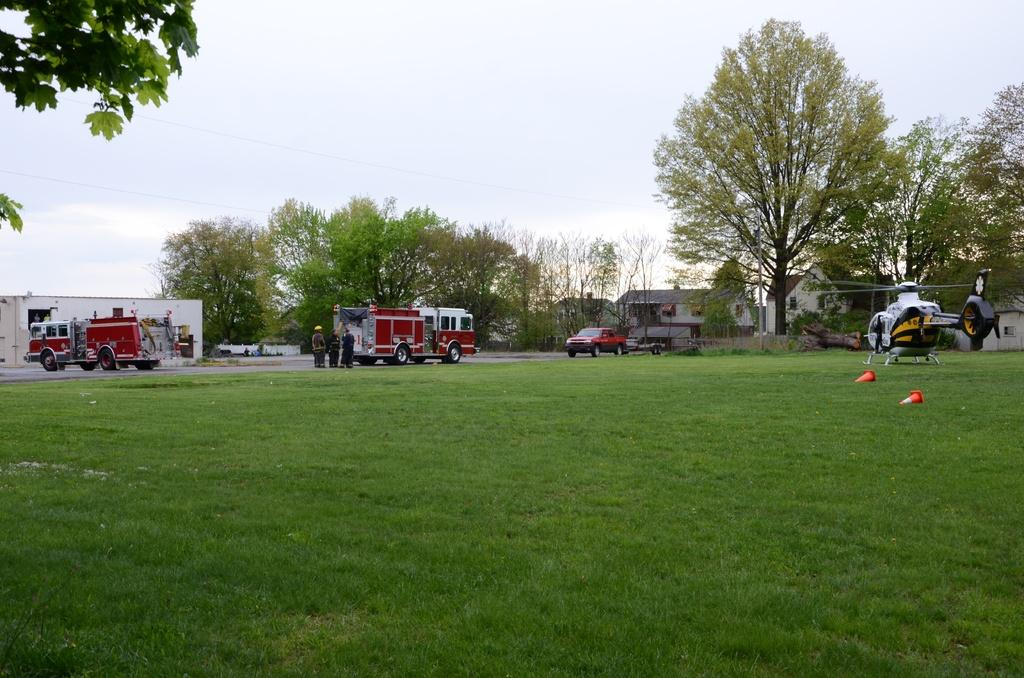What type of vegetation is present on the ground in the center of the image? There is grass on the ground in the center of the image. What can be seen in the background of the image? There are vehicles, trees, and buildings in the background of the image. What type of aircraft is located on the right side of the image? There is a helicopter on the right side of the image. What type of yam is being used as a prop in the image? There is no yam present in the image. Can you describe the educational institution visible in the image? There is no educational institution visible in the image. 